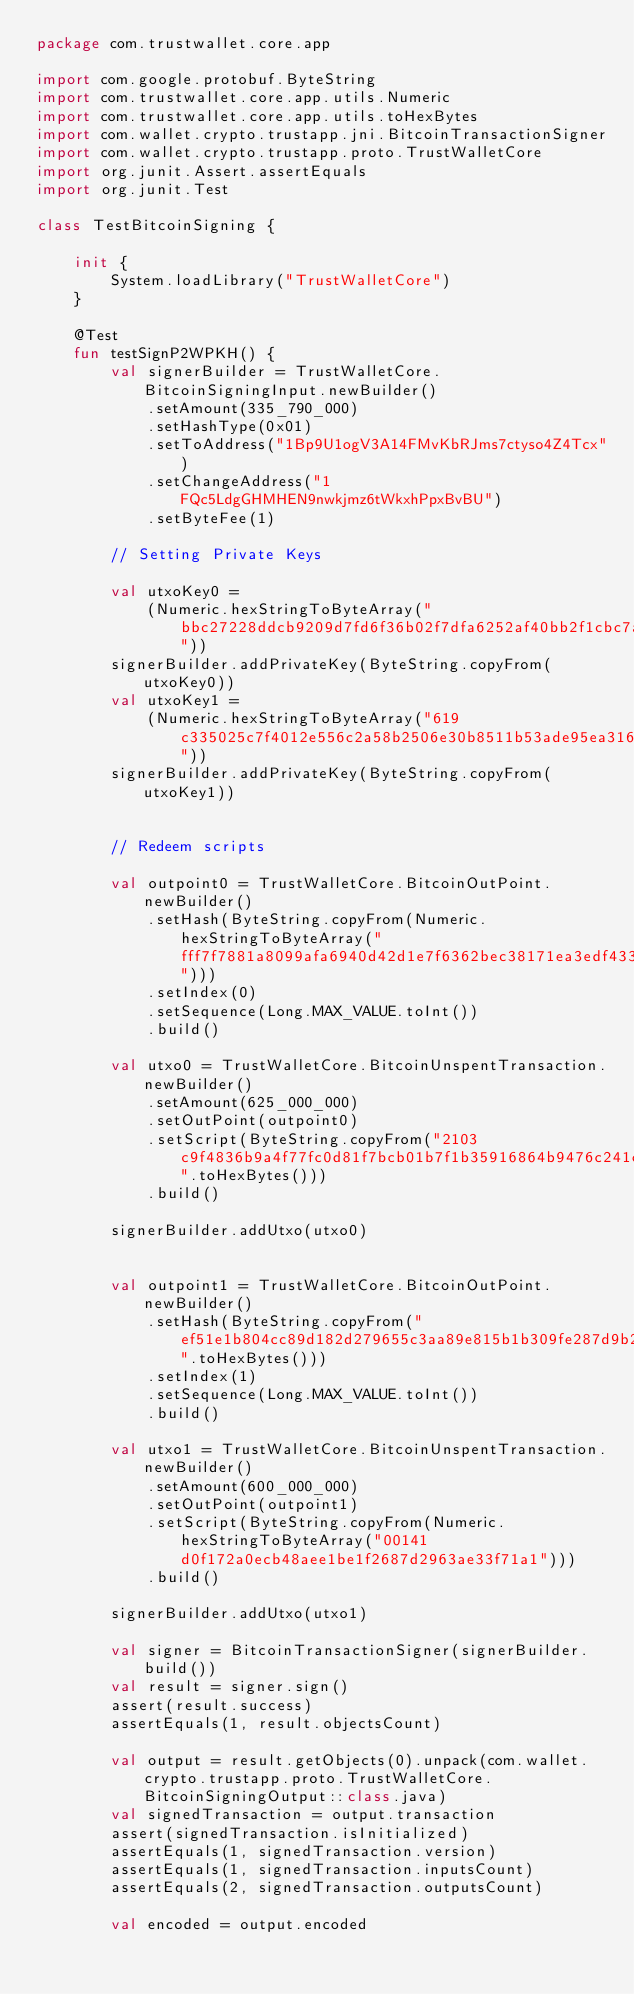Convert code to text. <code><loc_0><loc_0><loc_500><loc_500><_Kotlin_>package com.trustwallet.core.app

import com.google.protobuf.ByteString
import com.trustwallet.core.app.utils.Numeric
import com.trustwallet.core.app.utils.toHexBytes
import com.wallet.crypto.trustapp.jni.BitcoinTransactionSigner
import com.wallet.crypto.trustapp.proto.TrustWalletCore
import org.junit.Assert.assertEquals
import org.junit.Test

class TestBitcoinSigning {

    init {
        System.loadLibrary("TrustWalletCore")
    }

    @Test
    fun testSignP2WPKH() {
        val signerBuilder = TrustWalletCore.BitcoinSigningInput.newBuilder()
            .setAmount(335_790_000)
            .setHashType(0x01)
            .setToAddress("1Bp9U1ogV3A14FMvKbRJms7ctyso4Z4Tcx")
            .setChangeAddress("1FQc5LdgGHMHEN9nwkjmz6tWkxhPpxBvBU")
            .setByteFee(1)

        // Setting Private Keys

        val utxoKey0 =
            (Numeric.hexStringToByteArray("bbc27228ddcb9209d7fd6f36b02f7dfa6252af40bb2f1cbc7a557da8027ff866"))
        signerBuilder.addPrivateKey(ByteString.copyFrom(utxoKey0))
        val utxoKey1 =
            (Numeric.hexStringToByteArray("619c335025c7f4012e556c2a58b2506e30b8511b53ade95ea316fd8c3286feb9"))
        signerBuilder.addPrivateKey(ByteString.copyFrom(utxoKey1))


        // Redeem scripts

        val outpoint0 = TrustWalletCore.BitcoinOutPoint.newBuilder()
            .setHash(ByteString.copyFrom(Numeric.hexStringToByteArray("fff7f7881a8099afa6940d42d1e7f6362bec38171ea3edf433541db4e4ad969f")))
            .setIndex(0)
            .setSequence(Long.MAX_VALUE.toInt())
            .build()

        val utxo0 = TrustWalletCore.BitcoinUnspentTransaction.newBuilder()
            .setAmount(625_000_000)
            .setOutPoint(outpoint0)
            .setScript(ByteString.copyFrom("2103c9f4836b9a4f77fc0d81f7bcb01b7f1b35916864b9476c241ce9fc198bd25432ac".toHexBytes()))
            .build()

        signerBuilder.addUtxo(utxo0)


        val outpoint1 = TrustWalletCore.BitcoinOutPoint.newBuilder()
            .setHash(ByteString.copyFrom("ef51e1b804cc89d182d279655c3aa89e815b1b309fe287d9b2b55d57b90ec68a".toHexBytes()))
            .setIndex(1)
            .setSequence(Long.MAX_VALUE.toInt())
            .build()

        val utxo1 = TrustWalletCore.BitcoinUnspentTransaction.newBuilder()
            .setAmount(600_000_000)
            .setOutPoint(outpoint1)
            .setScript(ByteString.copyFrom(Numeric.hexStringToByteArray("00141d0f172a0ecb48aee1be1f2687d2963ae33f71a1")))
            .build()

        signerBuilder.addUtxo(utxo1)

        val signer = BitcoinTransactionSigner(signerBuilder.build())
        val result = signer.sign()
        assert(result.success)
        assertEquals(1, result.objectsCount)

        val output = result.getObjects(0).unpack(com.wallet.crypto.trustapp.proto.TrustWalletCore.BitcoinSigningOutput::class.java)
        val signedTransaction = output.transaction
        assert(signedTransaction.isInitialized)
        assertEquals(1, signedTransaction.version)
        assertEquals(1, signedTransaction.inputsCount)
        assertEquals(2, signedTransaction.outputsCount)

        val encoded = output.encoded</code> 